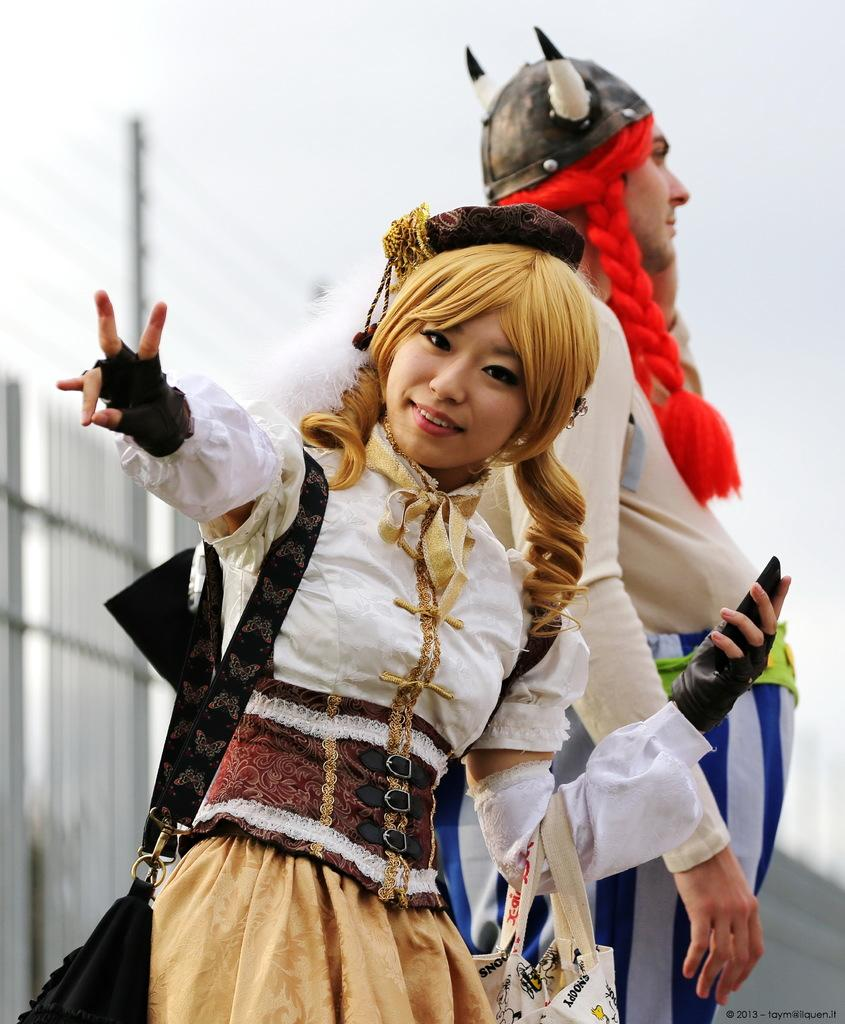How many people are in the image? There are two persons standing in the image. What is behind the persons in the image? There is a railing behind the persons. What can be seen in the background of the image? The sky is visible in the background of the image, and there is also a pole. What mathematical operation is being performed by the persons in the image? There is no indication in the image that the persons are performing any mathematical operation. 